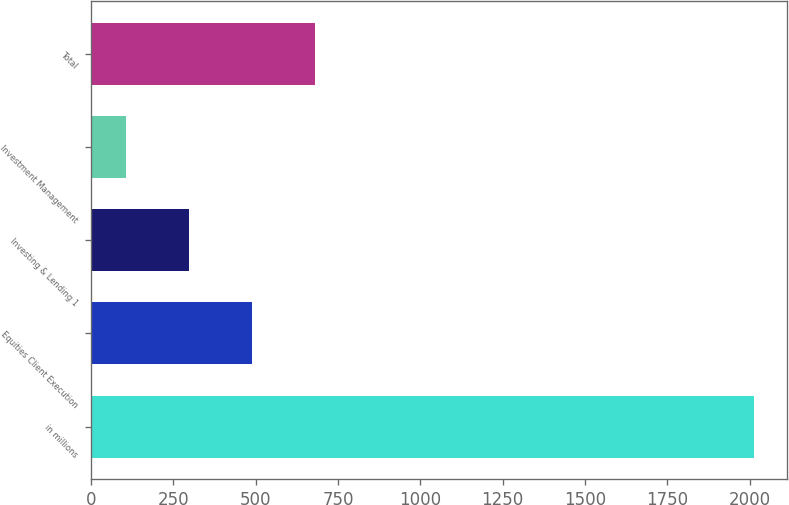Convert chart. <chart><loc_0><loc_0><loc_500><loc_500><bar_chart><fcel>in millions<fcel>Equities Client Execution<fcel>Investing & Lending 1<fcel>Investment Management<fcel>Total<nl><fcel>2013<fcel>489<fcel>298.5<fcel>108<fcel>679.5<nl></chart> 